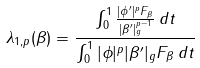Convert formula to latex. <formula><loc_0><loc_0><loc_500><loc_500>\lambda _ { 1 , p } ( \beta ) = \frac { \int _ { 0 } ^ { 1 } \frac { | \phi ^ { \prime } | ^ { p } F _ { \beta } } { | \beta ^ { \prime } | _ { g } ^ { p - 1 } } \, d t } { \int _ { 0 } ^ { 1 } | \phi | ^ { p } | \beta ^ { \prime } | _ { g } F _ { \beta } \, d t }</formula> 